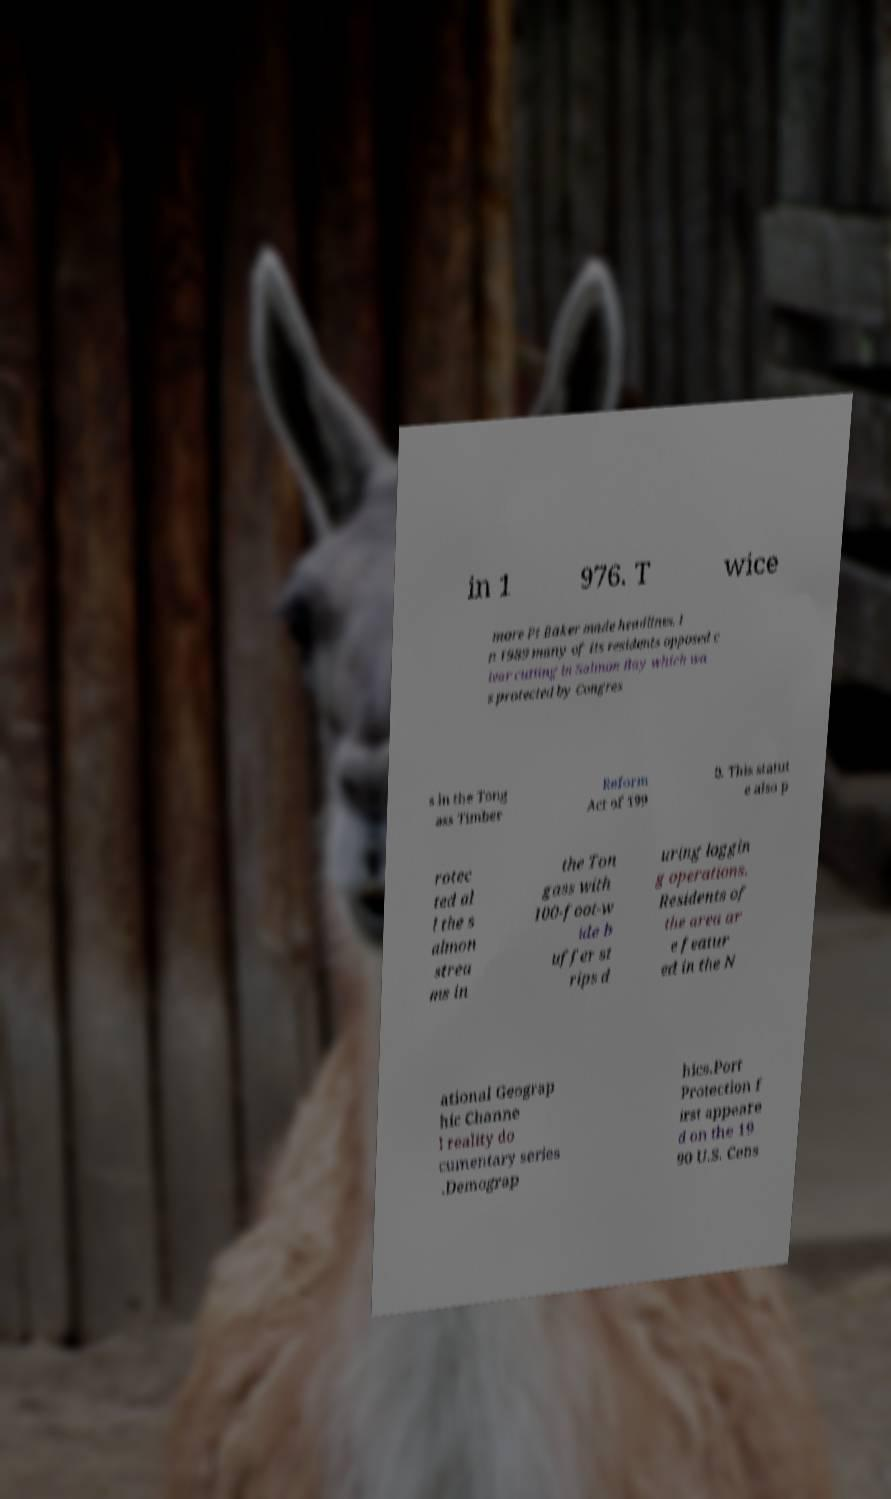Can you read and provide the text displayed in the image?This photo seems to have some interesting text. Can you extract and type it out for me? in 1 976. T wice more Pt Baker made headlines. I n 1989 many of its residents opposed c lear cutting in Salmon Bay which wa s protected by Congres s in the Tong ass Timber Reform Act of 199 0. This statut e also p rotec ted al l the s almon strea ms in the Ton gass with 100-foot-w ide b uffer st rips d uring loggin g operations. Residents of the area ar e featur ed in the N ational Geograp hic Channe l reality do cumentary series .Demograp hics.Port Protection f irst appeare d on the 19 90 U.S. Cens 